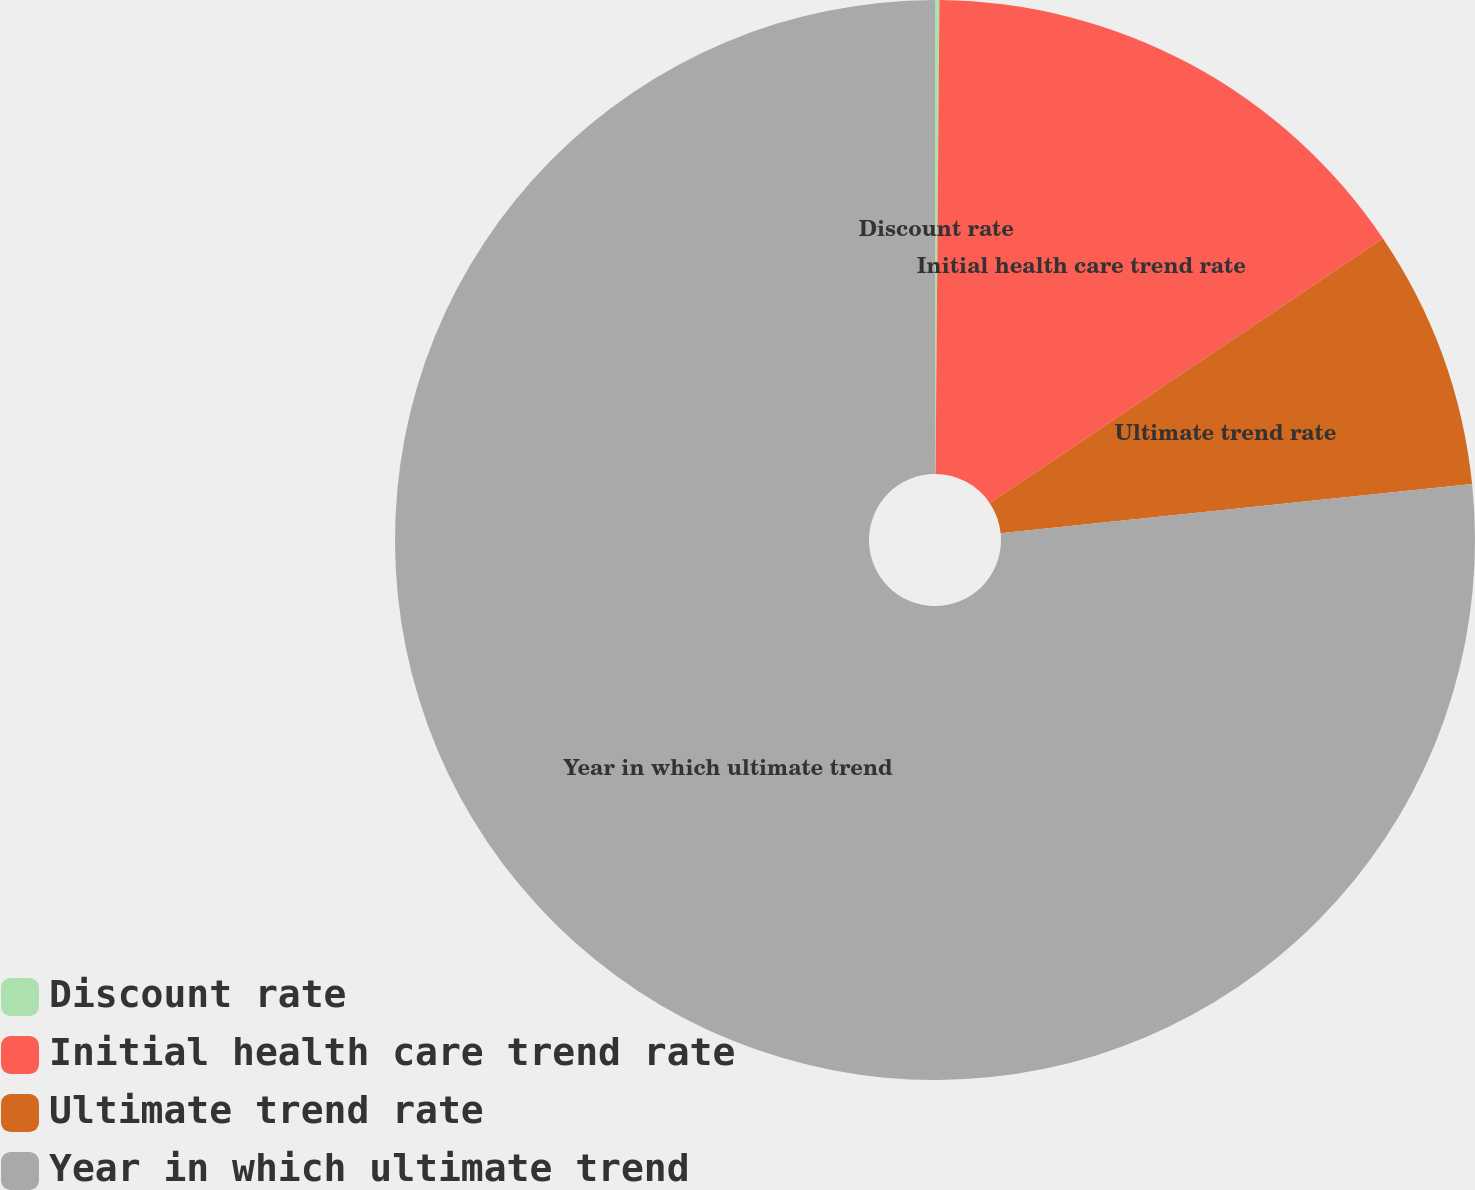Convert chart to OTSL. <chart><loc_0><loc_0><loc_500><loc_500><pie_chart><fcel>Discount rate<fcel>Initial health care trend rate<fcel>Ultimate trend rate<fcel>Year in which ultimate trend<nl><fcel>0.13%<fcel>15.44%<fcel>7.78%<fcel>76.65%<nl></chart> 